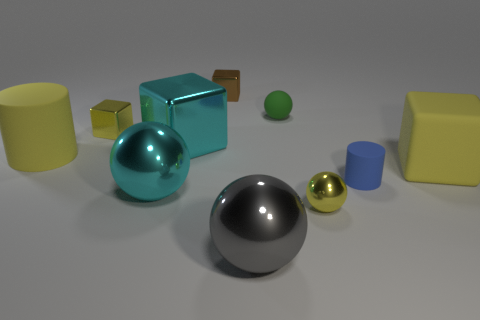Subtract all spheres. How many objects are left? 6 Add 1 metal objects. How many metal objects exist? 7 Subtract 0 gray blocks. How many objects are left? 10 Subtract all yellow cylinders. Subtract all large gray objects. How many objects are left? 8 Add 6 big rubber cubes. How many big rubber cubes are left? 7 